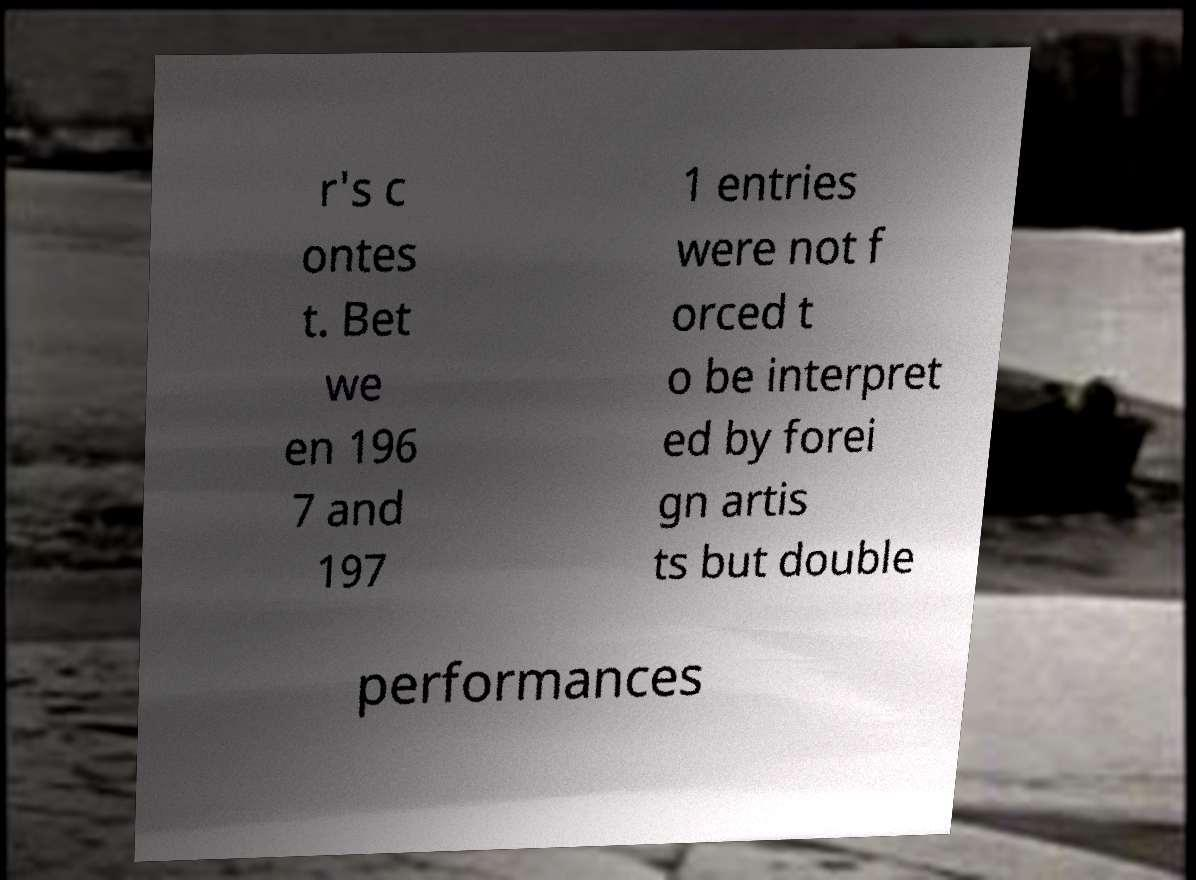Can you read and provide the text displayed in the image?This photo seems to have some interesting text. Can you extract and type it out for me? r's c ontes t. Bet we en 196 7 and 197 1 entries were not f orced t o be interpret ed by forei gn artis ts but double performances 